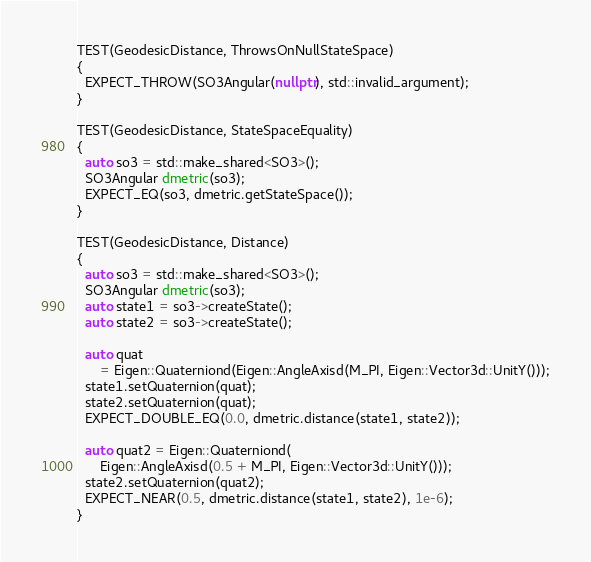Convert code to text. <code><loc_0><loc_0><loc_500><loc_500><_C++_>TEST(GeodesicDistance, ThrowsOnNullStateSpace)
{
  EXPECT_THROW(SO3Angular(nullptr), std::invalid_argument);
}

TEST(GeodesicDistance, StateSpaceEquality)
{
  auto so3 = std::make_shared<SO3>();
  SO3Angular dmetric(so3);
  EXPECT_EQ(so3, dmetric.getStateSpace());
}

TEST(GeodesicDistance, Distance)
{
  auto so3 = std::make_shared<SO3>();
  SO3Angular dmetric(so3);
  auto state1 = so3->createState();
  auto state2 = so3->createState();

  auto quat
      = Eigen::Quaterniond(Eigen::AngleAxisd(M_PI, Eigen::Vector3d::UnitY()));
  state1.setQuaternion(quat);
  state2.setQuaternion(quat);
  EXPECT_DOUBLE_EQ(0.0, dmetric.distance(state1, state2));

  auto quat2 = Eigen::Quaterniond(
      Eigen::AngleAxisd(0.5 + M_PI, Eigen::Vector3d::UnitY()));
  state2.setQuaternion(quat2);
  EXPECT_NEAR(0.5, dmetric.distance(state1, state2), 1e-6);
}
</code> 